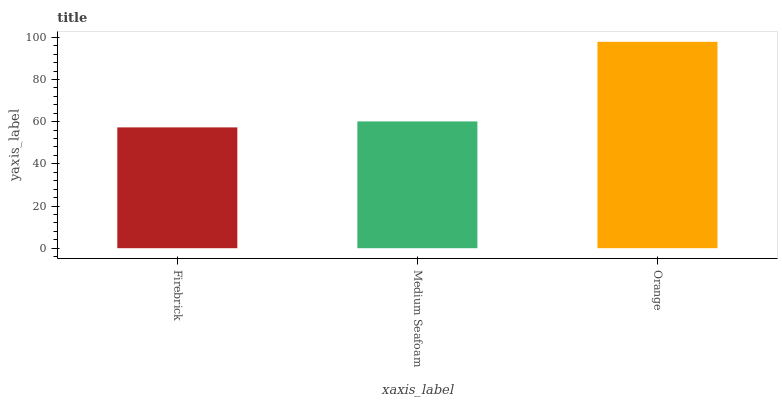Is Firebrick the minimum?
Answer yes or no. Yes. Is Orange the maximum?
Answer yes or no. Yes. Is Medium Seafoam the minimum?
Answer yes or no. No. Is Medium Seafoam the maximum?
Answer yes or no. No. Is Medium Seafoam greater than Firebrick?
Answer yes or no. Yes. Is Firebrick less than Medium Seafoam?
Answer yes or no. Yes. Is Firebrick greater than Medium Seafoam?
Answer yes or no. No. Is Medium Seafoam less than Firebrick?
Answer yes or no. No. Is Medium Seafoam the high median?
Answer yes or no. Yes. Is Medium Seafoam the low median?
Answer yes or no. Yes. Is Firebrick the high median?
Answer yes or no. No. Is Orange the low median?
Answer yes or no. No. 